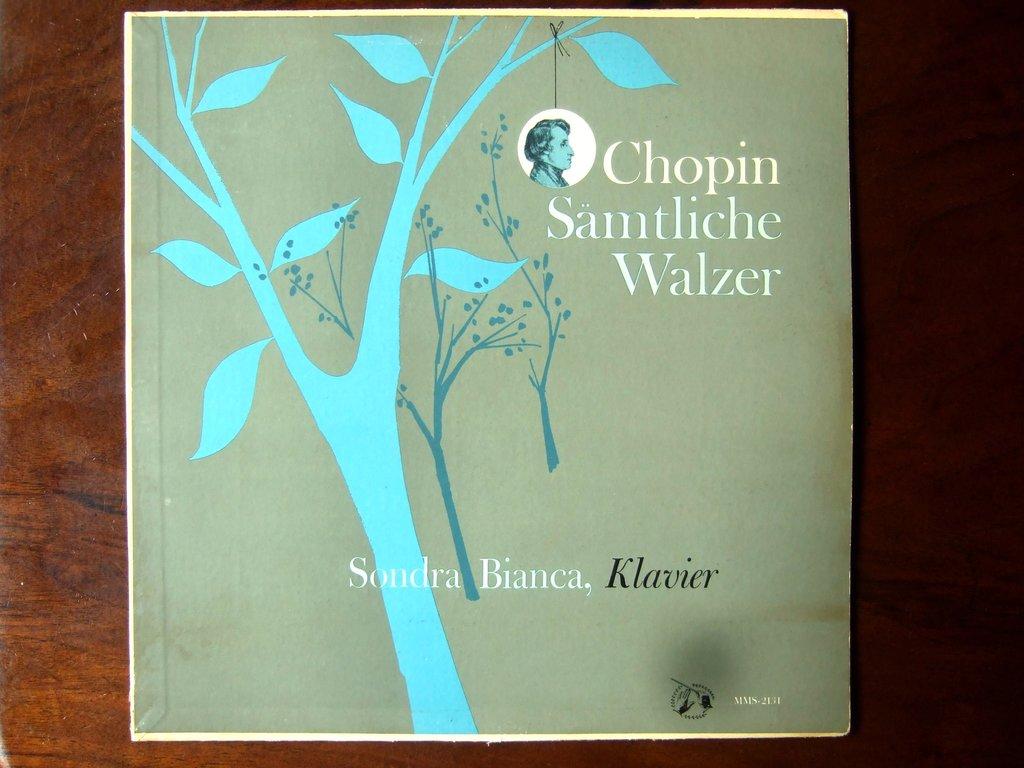What is the title of the book?
Provide a succinct answer. Chopin samtliche walzer. 